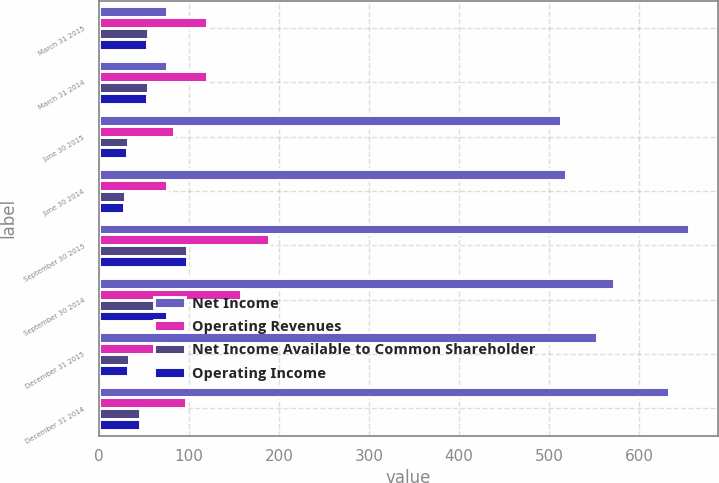<chart> <loc_0><loc_0><loc_500><loc_500><stacked_bar_chart><ecel><fcel>March 31 2015<fcel>March 31 2014<fcel>June 30 2015<fcel>June 30 2014<fcel>September 30 2015<fcel>September 30 2014<fcel>December 31 2015<fcel>December 31 2014<nl><fcel>Net Income<fcel>75<fcel>75<fcel>513<fcel>519<fcel>655<fcel>572<fcel>553<fcel>633<nl><fcel>Operating Revenues<fcel>120<fcel>120<fcel>83<fcel>75<fcel>189<fcel>158<fcel>74<fcel>97<nl><fcel>Net Income Available to Common Shareholder<fcel>54<fcel>54<fcel>32<fcel>29<fcel>98<fcel>75<fcel>33<fcel>46<nl><fcel>Operating Income<fcel>53<fcel>53<fcel>31<fcel>28<fcel>98<fcel>75<fcel>32<fcel>45<nl></chart> 